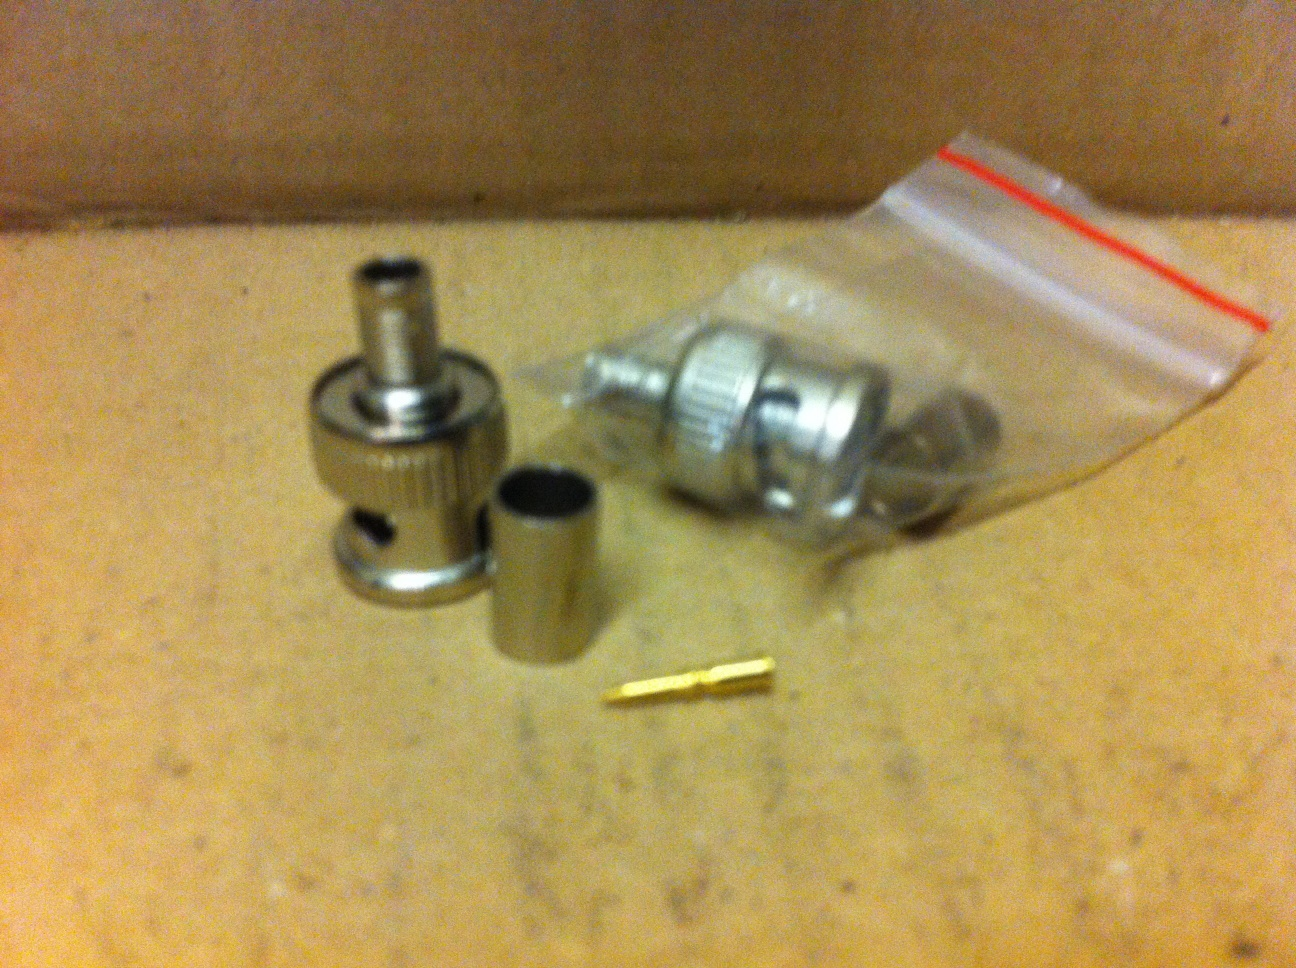What is this? This is a set of small metallic components that appear to be parts of a coaxial cable connector or a similar type of connector assembly. These parts are typically used in electronic or communication devices to join cables and ensure a proper signal transmission. 